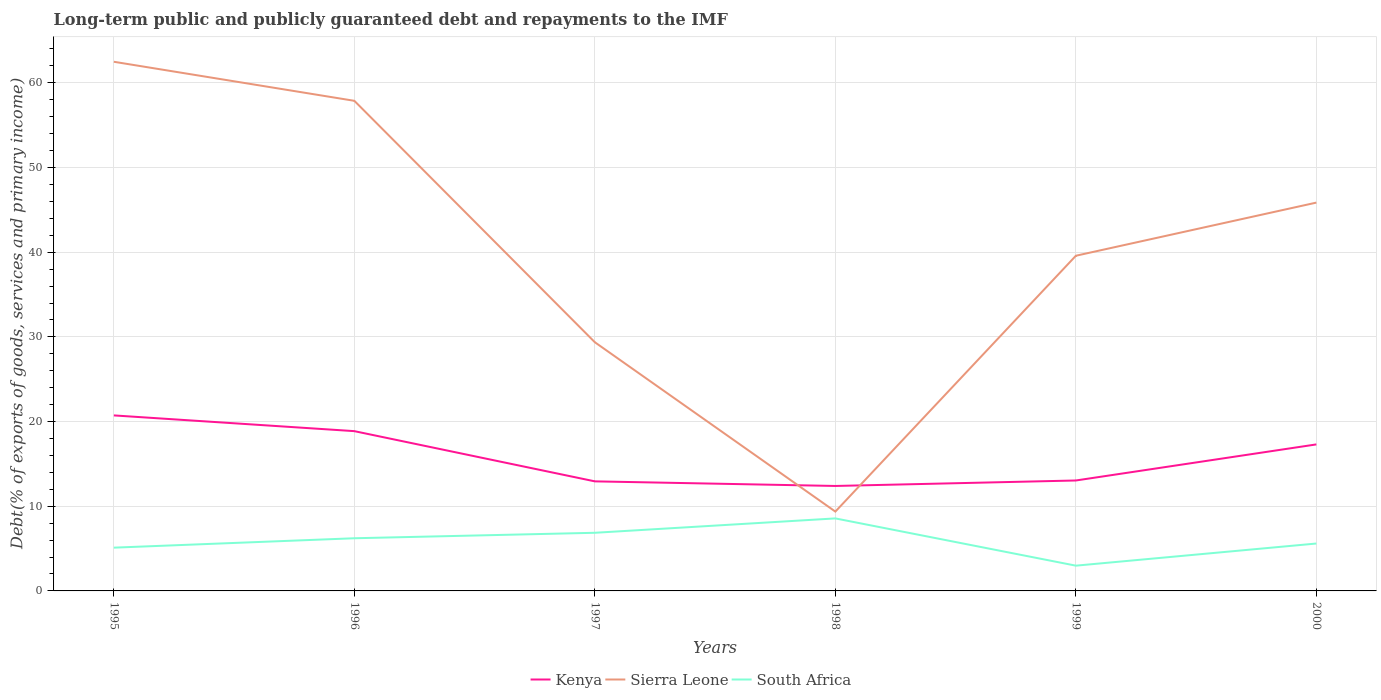How many different coloured lines are there?
Your answer should be very brief. 3. Does the line corresponding to Sierra Leone intersect with the line corresponding to South Africa?
Make the answer very short. No. Is the number of lines equal to the number of legend labels?
Keep it short and to the point. Yes. Across all years, what is the maximum debt and repayments in Kenya?
Give a very brief answer. 12.39. What is the total debt and repayments in South Africa in the graph?
Provide a short and direct response. -1.11. What is the difference between the highest and the second highest debt and repayments in Sierra Leone?
Provide a succinct answer. 53.12. What is the difference between the highest and the lowest debt and repayments in South Africa?
Make the answer very short. 3. How many years are there in the graph?
Your response must be concise. 6. What is the difference between two consecutive major ticks on the Y-axis?
Keep it short and to the point. 10. Does the graph contain any zero values?
Offer a terse response. No. Does the graph contain grids?
Provide a succinct answer. Yes. How many legend labels are there?
Your answer should be very brief. 3. How are the legend labels stacked?
Make the answer very short. Horizontal. What is the title of the graph?
Offer a very short reply. Long-term public and publicly guaranteed debt and repayments to the IMF. What is the label or title of the X-axis?
Keep it short and to the point. Years. What is the label or title of the Y-axis?
Provide a short and direct response. Debt(% of exports of goods, services and primary income). What is the Debt(% of exports of goods, services and primary income) of Kenya in 1995?
Offer a terse response. 20.73. What is the Debt(% of exports of goods, services and primary income) of Sierra Leone in 1995?
Make the answer very short. 62.49. What is the Debt(% of exports of goods, services and primary income) of South Africa in 1995?
Ensure brevity in your answer.  5.11. What is the Debt(% of exports of goods, services and primary income) of Kenya in 1996?
Your response must be concise. 18.87. What is the Debt(% of exports of goods, services and primary income) in Sierra Leone in 1996?
Keep it short and to the point. 57.88. What is the Debt(% of exports of goods, services and primary income) of South Africa in 1996?
Offer a terse response. 6.22. What is the Debt(% of exports of goods, services and primary income) of Kenya in 1997?
Your answer should be very brief. 12.94. What is the Debt(% of exports of goods, services and primary income) in Sierra Leone in 1997?
Keep it short and to the point. 29.37. What is the Debt(% of exports of goods, services and primary income) of South Africa in 1997?
Your response must be concise. 6.87. What is the Debt(% of exports of goods, services and primary income) in Kenya in 1998?
Provide a short and direct response. 12.39. What is the Debt(% of exports of goods, services and primary income) of Sierra Leone in 1998?
Provide a short and direct response. 9.37. What is the Debt(% of exports of goods, services and primary income) of South Africa in 1998?
Keep it short and to the point. 8.56. What is the Debt(% of exports of goods, services and primary income) in Kenya in 1999?
Offer a terse response. 13.04. What is the Debt(% of exports of goods, services and primary income) of Sierra Leone in 1999?
Offer a very short reply. 39.58. What is the Debt(% of exports of goods, services and primary income) in South Africa in 1999?
Give a very brief answer. 2.98. What is the Debt(% of exports of goods, services and primary income) in Kenya in 2000?
Keep it short and to the point. 17.3. What is the Debt(% of exports of goods, services and primary income) of Sierra Leone in 2000?
Ensure brevity in your answer.  45.86. What is the Debt(% of exports of goods, services and primary income) of South Africa in 2000?
Give a very brief answer. 5.6. Across all years, what is the maximum Debt(% of exports of goods, services and primary income) of Kenya?
Your answer should be compact. 20.73. Across all years, what is the maximum Debt(% of exports of goods, services and primary income) of Sierra Leone?
Offer a very short reply. 62.49. Across all years, what is the maximum Debt(% of exports of goods, services and primary income) in South Africa?
Offer a terse response. 8.56. Across all years, what is the minimum Debt(% of exports of goods, services and primary income) in Kenya?
Offer a terse response. 12.39. Across all years, what is the minimum Debt(% of exports of goods, services and primary income) of Sierra Leone?
Keep it short and to the point. 9.37. Across all years, what is the minimum Debt(% of exports of goods, services and primary income) in South Africa?
Your response must be concise. 2.98. What is the total Debt(% of exports of goods, services and primary income) in Kenya in the graph?
Make the answer very short. 95.27. What is the total Debt(% of exports of goods, services and primary income) of Sierra Leone in the graph?
Give a very brief answer. 244.54. What is the total Debt(% of exports of goods, services and primary income) of South Africa in the graph?
Ensure brevity in your answer.  35.34. What is the difference between the Debt(% of exports of goods, services and primary income) of Kenya in 1995 and that in 1996?
Your answer should be very brief. 1.86. What is the difference between the Debt(% of exports of goods, services and primary income) of Sierra Leone in 1995 and that in 1996?
Your answer should be very brief. 4.61. What is the difference between the Debt(% of exports of goods, services and primary income) of South Africa in 1995 and that in 1996?
Make the answer very short. -1.11. What is the difference between the Debt(% of exports of goods, services and primary income) in Kenya in 1995 and that in 1997?
Your answer should be very brief. 7.79. What is the difference between the Debt(% of exports of goods, services and primary income) in Sierra Leone in 1995 and that in 1997?
Your response must be concise. 33.12. What is the difference between the Debt(% of exports of goods, services and primary income) of South Africa in 1995 and that in 1997?
Your response must be concise. -1.76. What is the difference between the Debt(% of exports of goods, services and primary income) of Kenya in 1995 and that in 1998?
Provide a short and direct response. 8.33. What is the difference between the Debt(% of exports of goods, services and primary income) in Sierra Leone in 1995 and that in 1998?
Your answer should be compact. 53.12. What is the difference between the Debt(% of exports of goods, services and primary income) of South Africa in 1995 and that in 1998?
Make the answer very short. -3.45. What is the difference between the Debt(% of exports of goods, services and primary income) in Kenya in 1995 and that in 1999?
Your response must be concise. 7.68. What is the difference between the Debt(% of exports of goods, services and primary income) of Sierra Leone in 1995 and that in 1999?
Offer a very short reply. 22.91. What is the difference between the Debt(% of exports of goods, services and primary income) in South Africa in 1995 and that in 1999?
Offer a very short reply. 2.13. What is the difference between the Debt(% of exports of goods, services and primary income) in Kenya in 1995 and that in 2000?
Keep it short and to the point. 3.42. What is the difference between the Debt(% of exports of goods, services and primary income) in Sierra Leone in 1995 and that in 2000?
Your answer should be very brief. 16.63. What is the difference between the Debt(% of exports of goods, services and primary income) in South Africa in 1995 and that in 2000?
Offer a very short reply. -0.49. What is the difference between the Debt(% of exports of goods, services and primary income) of Kenya in 1996 and that in 1997?
Offer a very short reply. 5.93. What is the difference between the Debt(% of exports of goods, services and primary income) of Sierra Leone in 1996 and that in 1997?
Offer a terse response. 28.51. What is the difference between the Debt(% of exports of goods, services and primary income) in South Africa in 1996 and that in 1997?
Your answer should be compact. -0.65. What is the difference between the Debt(% of exports of goods, services and primary income) in Kenya in 1996 and that in 1998?
Offer a very short reply. 6.47. What is the difference between the Debt(% of exports of goods, services and primary income) of Sierra Leone in 1996 and that in 1998?
Provide a short and direct response. 48.51. What is the difference between the Debt(% of exports of goods, services and primary income) of South Africa in 1996 and that in 1998?
Provide a succinct answer. -2.34. What is the difference between the Debt(% of exports of goods, services and primary income) of Kenya in 1996 and that in 1999?
Your answer should be very brief. 5.83. What is the difference between the Debt(% of exports of goods, services and primary income) of Sierra Leone in 1996 and that in 1999?
Give a very brief answer. 18.3. What is the difference between the Debt(% of exports of goods, services and primary income) in South Africa in 1996 and that in 1999?
Your response must be concise. 3.24. What is the difference between the Debt(% of exports of goods, services and primary income) of Kenya in 1996 and that in 2000?
Provide a succinct answer. 1.57. What is the difference between the Debt(% of exports of goods, services and primary income) of Sierra Leone in 1996 and that in 2000?
Give a very brief answer. 12.02. What is the difference between the Debt(% of exports of goods, services and primary income) of South Africa in 1996 and that in 2000?
Your response must be concise. 0.62. What is the difference between the Debt(% of exports of goods, services and primary income) of Kenya in 1997 and that in 1998?
Your answer should be compact. 0.54. What is the difference between the Debt(% of exports of goods, services and primary income) of Sierra Leone in 1997 and that in 1998?
Your response must be concise. 20. What is the difference between the Debt(% of exports of goods, services and primary income) in South Africa in 1997 and that in 1998?
Your response must be concise. -1.7. What is the difference between the Debt(% of exports of goods, services and primary income) of Kenya in 1997 and that in 1999?
Give a very brief answer. -0.1. What is the difference between the Debt(% of exports of goods, services and primary income) of Sierra Leone in 1997 and that in 1999?
Ensure brevity in your answer.  -10.21. What is the difference between the Debt(% of exports of goods, services and primary income) in South Africa in 1997 and that in 1999?
Your answer should be compact. 3.88. What is the difference between the Debt(% of exports of goods, services and primary income) of Kenya in 1997 and that in 2000?
Provide a succinct answer. -4.36. What is the difference between the Debt(% of exports of goods, services and primary income) in Sierra Leone in 1997 and that in 2000?
Provide a short and direct response. -16.49. What is the difference between the Debt(% of exports of goods, services and primary income) in South Africa in 1997 and that in 2000?
Ensure brevity in your answer.  1.27. What is the difference between the Debt(% of exports of goods, services and primary income) of Kenya in 1998 and that in 1999?
Provide a short and direct response. -0.65. What is the difference between the Debt(% of exports of goods, services and primary income) in Sierra Leone in 1998 and that in 1999?
Make the answer very short. -30.21. What is the difference between the Debt(% of exports of goods, services and primary income) in South Africa in 1998 and that in 1999?
Provide a short and direct response. 5.58. What is the difference between the Debt(% of exports of goods, services and primary income) of Kenya in 1998 and that in 2000?
Provide a short and direct response. -4.91. What is the difference between the Debt(% of exports of goods, services and primary income) of Sierra Leone in 1998 and that in 2000?
Your answer should be very brief. -36.49. What is the difference between the Debt(% of exports of goods, services and primary income) of South Africa in 1998 and that in 2000?
Your response must be concise. 2.97. What is the difference between the Debt(% of exports of goods, services and primary income) of Kenya in 1999 and that in 2000?
Offer a very short reply. -4.26. What is the difference between the Debt(% of exports of goods, services and primary income) in Sierra Leone in 1999 and that in 2000?
Your answer should be very brief. -6.28. What is the difference between the Debt(% of exports of goods, services and primary income) in South Africa in 1999 and that in 2000?
Offer a terse response. -2.61. What is the difference between the Debt(% of exports of goods, services and primary income) of Kenya in 1995 and the Debt(% of exports of goods, services and primary income) of Sierra Leone in 1996?
Make the answer very short. -37.15. What is the difference between the Debt(% of exports of goods, services and primary income) of Kenya in 1995 and the Debt(% of exports of goods, services and primary income) of South Africa in 1996?
Your answer should be compact. 14.51. What is the difference between the Debt(% of exports of goods, services and primary income) of Sierra Leone in 1995 and the Debt(% of exports of goods, services and primary income) of South Africa in 1996?
Offer a very short reply. 56.27. What is the difference between the Debt(% of exports of goods, services and primary income) in Kenya in 1995 and the Debt(% of exports of goods, services and primary income) in Sierra Leone in 1997?
Make the answer very short. -8.64. What is the difference between the Debt(% of exports of goods, services and primary income) in Kenya in 1995 and the Debt(% of exports of goods, services and primary income) in South Africa in 1997?
Your answer should be very brief. 13.86. What is the difference between the Debt(% of exports of goods, services and primary income) of Sierra Leone in 1995 and the Debt(% of exports of goods, services and primary income) of South Africa in 1997?
Offer a terse response. 55.62. What is the difference between the Debt(% of exports of goods, services and primary income) of Kenya in 1995 and the Debt(% of exports of goods, services and primary income) of Sierra Leone in 1998?
Ensure brevity in your answer.  11.36. What is the difference between the Debt(% of exports of goods, services and primary income) in Kenya in 1995 and the Debt(% of exports of goods, services and primary income) in South Africa in 1998?
Offer a terse response. 12.16. What is the difference between the Debt(% of exports of goods, services and primary income) in Sierra Leone in 1995 and the Debt(% of exports of goods, services and primary income) in South Africa in 1998?
Provide a succinct answer. 53.92. What is the difference between the Debt(% of exports of goods, services and primary income) in Kenya in 1995 and the Debt(% of exports of goods, services and primary income) in Sierra Leone in 1999?
Provide a succinct answer. -18.85. What is the difference between the Debt(% of exports of goods, services and primary income) of Kenya in 1995 and the Debt(% of exports of goods, services and primary income) of South Africa in 1999?
Provide a succinct answer. 17.74. What is the difference between the Debt(% of exports of goods, services and primary income) in Sierra Leone in 1995 and the Debt(% of exports of goods, services and primary income) in South Africa in 1999?
Give a very brief answer. 59.5. What is the difference between the Debt(% of exports of goods, services and primary income) in Kenya in 1995 and the Debt(% of exports of goods, services and primary income) in Sierra Leone in 2000?
Your answer should be compact. -25.13. What is the difference between the Debt(% of exports of goods, services and primary income) in Kenya in 1995 and the Debt(% of exports of goods, services and primary income) in South Africa in 2000?
Your answer should be compact. 15.13. What is the difference between the Debt(% of exports of goods, services and primary income) of Sierra Leone in 1995 and the Debt(% of exports of goods, services and primary income) of South Africa in 2000?
Give a very brief answer. 56.89. What is the difference between the Debt(% of exports of goods, services and primary income) in Kenya in 1996 and the Debt(% of exports of goods, services and primary income) in Sierra Leone in 1997?
Make the answer very short. -10.5. What is the difference between the Debt(% of exports of goods, services and primary income) of Kenya in 1996 and the Debt(% of exports of goods, services and primary income) of South Africa in 1997?
Ensure brevity in your answer.  12. What is the difference between the Debt(% of exports of goods, services and primary income) in Sierra Leone in 1996 and the Debt(% of exports of goods, services and primary income) in South Africa in 1997?
Provide a succinct answer. 51.01. What is the difference between the Debt(% of exports of goods, services and primary income) of Kenya in 1996 and the Debt(% of exports of goods, services and primary income) of Sierra Leone in 1998?
Give a very brief answer. 9.5. What is the difference between the Debt(% of exports of goods, services and primary income) of Kenya in 1996 and the Debt(% of exports of goods, services and primary income) of South Africa in 1998?
Provide a short and direct response. 10.3. What is the difference between the Debt(% of exports of goods, services and primary income) of Sierra Leone in 1996 and the Debt(% of exports of goods, services and primary income) of South Africa in 1998?
Your answer should be compact. 49.31. What is the difference between the Debt(% of exports of goods, services and primary income) in Kenya in 1996 and the Debt(% of exports of goods, services and primary income) in Sierra Leone in 1999?
Your response must be concise. -20.71. What is the difference between the Debt(% of exports of goods, services and primary income) of Kenya in 1996 and the Debt(% of exports of goods, services and primary income) of South Africa in 1999?
Keep it short and to the point. 15.89. What is the difference between the Debt(% of exports of goods, services and primary income) in Sierra Leone in 1996 and the Debt(% of exports of goods, services and primary income) in South Africa in 1999?
Provide a succinct answer. 54.89. What is the difference between the Debt(% of exports of goods, services and primary income) in Kenya in 1996 and the Debt(% of exports of goods, services and primary income) in Sierra Leone in 2000?
Offer a very short reply. -26.99. What is the difference between the Debt(% of exports of goods, services and primary income) of Kenya in 1996 and the Debt(% of exports of goods, services and primary income) of South Africa in 2000?
Provide a succinct answer. 13.27. What is the difference between the Debt(% of exports of goods, services and primary income) in Sierra Leone in 1996 and the Debt(% of exports of goods, services and primary income) in South Africa in 2000?
Ensure brevity in your answer.  52.28. What is the difference between the Debt(% of exports of goods, services and primary income) of Kenya in 1997 and the Debt(% of exports of goods, services and primary income) of Sierra Leone in 1998?
Provide a succinct answer. 3.57. What is the difference between the Debt(% of exports of goods, services and primary income) in Kenya in 1997 and the Debt(% of exports of goods, services and primary income) in South Africa in 1998?
Provide a short and direct response. 4.37. What is the difference between the Debt(% of exports of goods, services and primary income) in Sierra Leone in 1997 and the Debt(% of exports of goods, services and primary income) in South Africa in 1998?
Make the answer very short. 20.8. What is the difference between the Debt(% of exports of goods, services and primary income) of Kenya in 1997 and the Debt(% of exports of goods, services and primary income) of Sierra Leone in 1999?
Provide a short and direct response. -26.64. What is the difference between the Debt(% of exports of goods, services and primary income) of Kenya in 1997 and the Debt(% of exports of goods, services and primary income) of South Africa in 1999?
Offer a very short reply. 9.96. What is the difference between the Debt(% of exports of goods, services and primary income) of Sierra Leone in 1997 and the Debt(% of exports of goods, services and primary income) of South Africa in 1999?
Your answer should be compact. 26.38. What is the difference between the Debt(% of exports of goods, services and primary income) in Kenya in 1997 and the Debt(% of exports of goods, services and primary income) in Sierra Leone in 2000?
Give a very brief answer. -32.92. What is the difference between the Debt(% of exports of goods, services and primary income) in Kenya in 1997 and the Debt(% of exports of goods, services and primary income) in South Africa in 2000?
Offer a very short reply. 7.34. What is the difference between the Debt(% of exports of goods, services and primary income) in Sierra Leone in 1997 and the Debt(% of exports of goods, services and primary income) in South Africa in 2000?
Make the answer very short. 23.77. What is the difference between the Debt(% of exports of goods, services and primary income) of Kenya in 1998 and the Debt(% of exports of goods, services and primary income) of Sierra Leone in 1999?
Your answer should be very brief. -27.19. What is the difference between the Debt(% of exports of goods, services and primary income) in Kenya in 1998 and the Debt(% of exports of goods, services and primary income) in South Africa in 1999?
Keep it short and to the point. 9.41. What is the difference between the Debt(% of exports of goods, services and primary income) in Sierra Leone in 1998 and the Debt(% of exports of goods, services and primary income) in South Africa in 1999?
Make the answer very short. 6.39. What is the difference between the Debt(% of exports of goods, services and primary income) in Kenya in 1998 and the Debt(% of exports of goods, services and primary income) in Sierra Leone in 2000?
Offer a very short reply. -33.46. What is the difference between the Debt(% of exports of goods, services and primary income) in Kenya in 1998 and the Debt(% of exports of goods, services and primary income) in South Africa in 2000?
Give a very brief answer. 6.8. What is the difference between the Debt(% of exports of goods, services and primary income) of Sierra Leone in 1998 and the Debt(% of exports of goods, services and primary income) of South Africa in 2000?
Give a very brief answer. 3.77. What is the difference between the Debt(% of exports of goods, services and primary income) in Kenya in 1999 and the Debt(% of exports of goods, services and primary income) in Sierra Leone in 2000?
Your answer should be compact. -32.82. What is the difference between the Debt(% of exports of goods, services and primary income) in Kenya in 1999 and the Debt(% of exports of goods, services and primary income) in South Africa in 2000?
Keep it short and to the point. 7.44. What is the difference between the Debt(% of exports of goods, services and primary income) in Sierra Leone in 1999 and the Debt(% of exports of goods, services and primary income) in South Africa in 2000?
Give a very brief answer. 33.98. What is the average Debt(% of exports of goods, services and primary income) of Kenya per year?
Your answer should be very brief. 15.88. What is the average Debt(% of exports of goods, services and primary income) of Sierra Leone per year?
Your answer should be very brief. 40.76. What is the average Debt(% of exports of goods, services and primary income) of South Africa per year?
Provide a succinct answer. 5.89. In the year 1995, what is the difference between the Debt(% of exports of goods, services and primary income) of Kenya and Debt(% of exports of goods, services and primary income) of Sierra Leone?
Your answer should be very brief. -41.76. In the year 1995, what is the difference between the Debt(% of exports of goods, services and primary income) of Kenya and Debt(% of exports of goods, services and primary income) of South Africa?
Ensure brevity in your answer.  15.62. In the year 1995, what is the difference between the Debt(% of exports of goods, services and primary income) of Sierra Leone and Debt(% of exports of goods, services and primary income) of South Africa?
Offer a terse response. 57.38. In the year 1996, what is the difference between the Debt(% of exports of goods, services and primary income) of Kenya and Debt(% of exports of goods, services and primary income) of Sierra Leone?
Give a very brief answer. -39.01. In the year 1996, what is the difference between the Debt(% of exports of goods, services and primary income) in Kenya and Debt(% of exports of goods, services and primary income) in South Africa?
Ensure brevity in your answer.  12.65. In the year 1996, what is the difference between the Debt(% of exports of goods, services and primary income) in Sierra Leone and Debt(% of exports of goods, services and primary income) in South Africa?
Give a very brief answer. 51.66. In the year 1997, what is the difference between the Debt(% of exports of goods, services and primary income) in Kenya and Debt(% of exports of goods, services and primary income) in Sierra Leone?
Offer a terse response. -16.43. In the year 1997, what is the difference between the Debt(% of exports of goods, services and primary income) in Kenya and Debt(% of exports of goods, services and primary income) in South Africa?
Provide a short and direct response. 6.07. In the year 1997, what is the difference between the Debt(% of exports of goods, services and primary income) in Sierra Leone and Debt(% of exports of goods, services and primary income) in South Africa?
Make the answer very short. 22.5. In the year 1998, what is the difference between the Debt(% of exports of goods, services and primary income) in Kenya and Debt(% of exports of goods, services and primary income) in Sierra Leone?
Ensure brevity in your answer.  3.03. In the year 1998, what is the difference between the Debt(% of exports of goods, services and primary income) in Kenya and Debt(% of exports of goods, services and primary income) in South Africa?
Ensure brevity in your answer.  3.83. In the year 1998, what is the difference between the Debt(% of exports of goods, services and primary income) of Sierra Leone and Debt(% of exports of goods, services and primary income) of South Africa?
Your answer should be compact. 0.81. In the year 1999, what is the difference between the Debt(% of exports of goods, services and primary income) of Kenya and Debt(% of exports of goods, services and primary income) of Sierra Leone?
Provide a short and direct response. -26.54. In the year 1999, what is the difference between the Debt(% of exports of goods, services and primary income) in Kenya and Debt(% of exports of goods, services and primary income) in South Africa?
Your answer should be very brief. 10.06. In the year 1999, what is the difference between the Debt(% of exports of goods, services and primary income) of Sierra Leone and Debt(% of exports of goods, services and primary income) of South Africa?
Keep it short and to the point. 36.6. In the year 2000, what is the difference between the Debt(% of exports of goods, services and primary income) of Kenya and Debt(% of exports of goods, services and primary income) of Sierra Leone?
Offer a terse response. -28.55. In the year 2000, what is the difference between the Debt(% of exports of goods, services and primary income) of Kenya and Debt(% of exports of goods, services and primary income) of South Africa?
Your response must be concise. 11.71. In the year 2000, what is the difference between the Debt(% of exports of goods, services and primary income) of Sierra Leone and Debt(% of exports of goods, services and primary income) of South Africa?
Your response must be concise. 40.26. What is the ratio of the Debt(% of exports of goods, services and primary income) of Kenya in 1995 to that in 1996?
Provide a short and direct response. 1.1. What is the ratio of the Debt(% of exports of goods, services and primary income) of Sierra Leone in 1995 to that in 1996?
Ensure brevity in your answer.  1.08. What is the ratio of the Debt(% of exports of goods, services and primary income) of South Africa in 1995 to that in 1996?
Your answer should be compact. 0.82. What is the ratio of the Debt(% of exports of goods, services and primary income) in Kenya in 1995 to that in 1997?
Your answer should be compact. 1.6. What is the ratio of the Debt(% of exports of goods, services and primary income) in Sierra Leone in 1995 to that in 1997?
Offer a terse response. 2.13. What is the ratio of the Debt(% of exports of goods, services and primary income) in South Africa in 1995 to that in 1997?
Give a very brief answer. 0.74. What is the ratio of the Debt(% of exports of goods, services and primary income) of Kenya in 1995 to that in 1998?
Your answer should be compact. 1.67. What is the ratio of the Debt(% of exports of goods, services and primary income) in Sierra Leone in 1995 to that in 1998?
Keep it short and to the point. 6.67. What is the ratio of the Debt(% of exports of goods, services and primary income) in South Africa in 1995 to that in 1998?
Offer a terse response. 0.6. What is the ratio of the Debt(% of exports of goods, services and primary income) in Kenya in 1995 to that in 1999?
Provide a succinct answer. 1.59. What is the ratio of the Debt(% of exports of goods, services and primary income) in Sierra Leone in 1995 to that in 1999?
Offer a terse response. 1.58. What is the ratio of the Debt(% of exports of goods, services and primary income) of South Africa in 1995 to that in 1999?
Offer a very short reply. 1.71. What is the ratio of the Debt(% of exports of goods, services and primary income) of Kenya in 1995 to that in 2000?
Offer a terse response. 1.2. What is the ratio of the Debt(% of exports of goods, services and primary income) in Sierra Leone in 1995 to that in 2000?
Your response must be concise. 1.36. What is the ratio of the Debt(% of exports of goods, services and primary income) in South Africa in 1995 to that in 2000?
Offer a very short reply. 0.91. What is the ratio of the Debt(% of exports of goods, services and primary income) of Kenya in 1996 to that in 1997?
Offer a very short reply. 1.46. What is the ratio of the Debt(% of exports of goods, services and primary income) in Sierra Leone in 1996 to that in 1997?
Ensure brevity in your answer.  1.97. What is the ratio of the Debt(% of exports of goods, services and primary income) of South Africa in 1996 to that in 1997?
Provide a succinct answer. 0.91. What is the ratio of the Debt(% of exports of goods, services and primary income) of Kenya in 1996 to that in 1998?
Make the answer very short. 1.52. What is the ratio of the Debt(% of exports of goods, services and primary income) in Sierra Leone in 1996 to that in 1998?
Provide a short and direct response. 6.18. What is the ratio of the Debt(% of exports of goods, services and primary income) of South Africa in 1996 to that in 1998?
Keep it short and to the point. 0.73. What is the ratio of the Debt(% of exports of goods, services and primary income) of Kenya in 1996 to that in 1999?
Provide a short and direct response. 1.45. What is the ratio of the Debt(% of exports of goods, services and primary income) in Sierra Leone in 1996 to that in 1999?
Your answer should be compact. 1.46. What is the ratio of the Debt(% of exports of goods, services and primary income) in South Africa in 1996 to that in 1999?
Give a very brief answer. 2.09. What is the ratio of the Debt(% of exports of goods, services and primary income) in Kenya in 1996 to that in 2000?
Make the answer very short. 1.09. What is the ratio of the Debt(% of exports of goods, services and primary income) in Sierra Leone in 1996 to that in 2000?
Provide a short and direct response. 1.26. What is the ratio of the Debt(% of exports of goods, services and primary income) of South Africa in 1996 to that in 2000?
Provide a short and direct response. 1.11. What is the ratio of the Debt(% of exports of goods, services and primary income) in Kenya in 1997 to that in 1998?
Keep it short and to the point. 1.04. What is the ratio of the Debt(% of exports of goods, services and primary income) of Sierra Leone in 1997 to that in 1998?
Your response must be concise. 3.13. What is the ratio of the Debt(% of exports of goods, services and primary income) in South Africa in 1997 to that in 1998?
Make the answer very short. 0.8. What is the ratio of the Debt(% of exports of goods, services and primary income) in Kenya in 1997 to that in 1999?
Give a very brief answer. 0.99. What is the ratio of the Debt(% of exports of goods, services and primary income) in Sierra Leone in 1997 to that in 1999?
Your answer should be very brief. 0.74. What is the ratio of the Debt(% of exports of goods, services and primary income) of South Africa in 1997 to that in 1999?
Provide a short and direct response. 2.3. What is the ratio of the Debt(% of exports of goods, services and primary income) of Kenya in 1997 to that in 2000?
Keep it short and to the point. 0.75. What is the ratio of the Debt(% of exports of goods, services and primary income) in Sierra Leone in 1997 to that in 2000?
Your answer should be compact. 0.64. What is the ratio of the Debt(% of exports of goods, services and primary income) in South Africa in 1997 to that in 2000?
Your answer should be compact. 1.23. What is the ratio of the Debt(% of exports of goods, services and primary income) in Kenya in 1998 to that in 1999?
Provide a succinct answer. 0.95. What is the ratio of the Debt(% of exports of goods, services and primary income) in Sierra Leone in 1998 to that in 1999?
Keep it short and to the point. 0.24. What is the ratio of the Debt(% of exports of goods, services and primary income) of South Africa in 1998 to that in 1999?
Ensure brevity in your answer.  2.87. What is the ratio of the Debt(% of exports of goods, services and primary income) in Kenya in 1998 to that in 2000?
Offer a terse response. 0.72. What is the ratio of the Debt(% of exports of goods, services and primary income) in Sierra Leone in 1998 to that in 2000?
Provide a succinct answer. 0.2. What is the ratio of the Debt(% of exports of goods, services and primary income) in South Africa in 1998 to that in 2000?
Your response must be concise. 1.53. What is the ratio of the Debt(% of exports of goods, services and primary income) of Kenya in 1999 to that in 2000?
Ensure brevity in your answer.  0.75. What is the ratio of the Debt(% of exports of goods, services and primary income) of Sierra Leone in 1999 to that in 2000?
Offer a terse response. 0.86. What is the ratio of the Debt(% of exports of goods, services and primary income) of South Africa in 1999 to that in 2000?
Ensure brevity in your answer.  0.53. What is the difference between the highest and the second highest Debt(% of exports of goods, services and primary income) of Kenya?
Ensure brevity in your answer.  1.86. What is the difference between the highest and the second highest Debt(% of exports of goods, services and primary income) of Sierra Leone?
Give a very brief answer. 4.61. What is the difference between the highest and the second highest Debt(% of exports of goods, services and primary income) in South Africa?
Provide a succinct answer. 1.7. What is the difference between the highest and the lowest Debt(% of exports of goods, services and primary income) in Kenya?
Provide a succinct answer. 8.33. What is the difference between the highest and the lowest Debt(% of exports of goods, services and primary income) of Sierra Leone?
Keep it short and to the point. 53.12. What is the difference between the highest and the lowest Debt(% of exports of goods, services and primary income) in South Africa?
Provide a short and direct response. 5.58. 